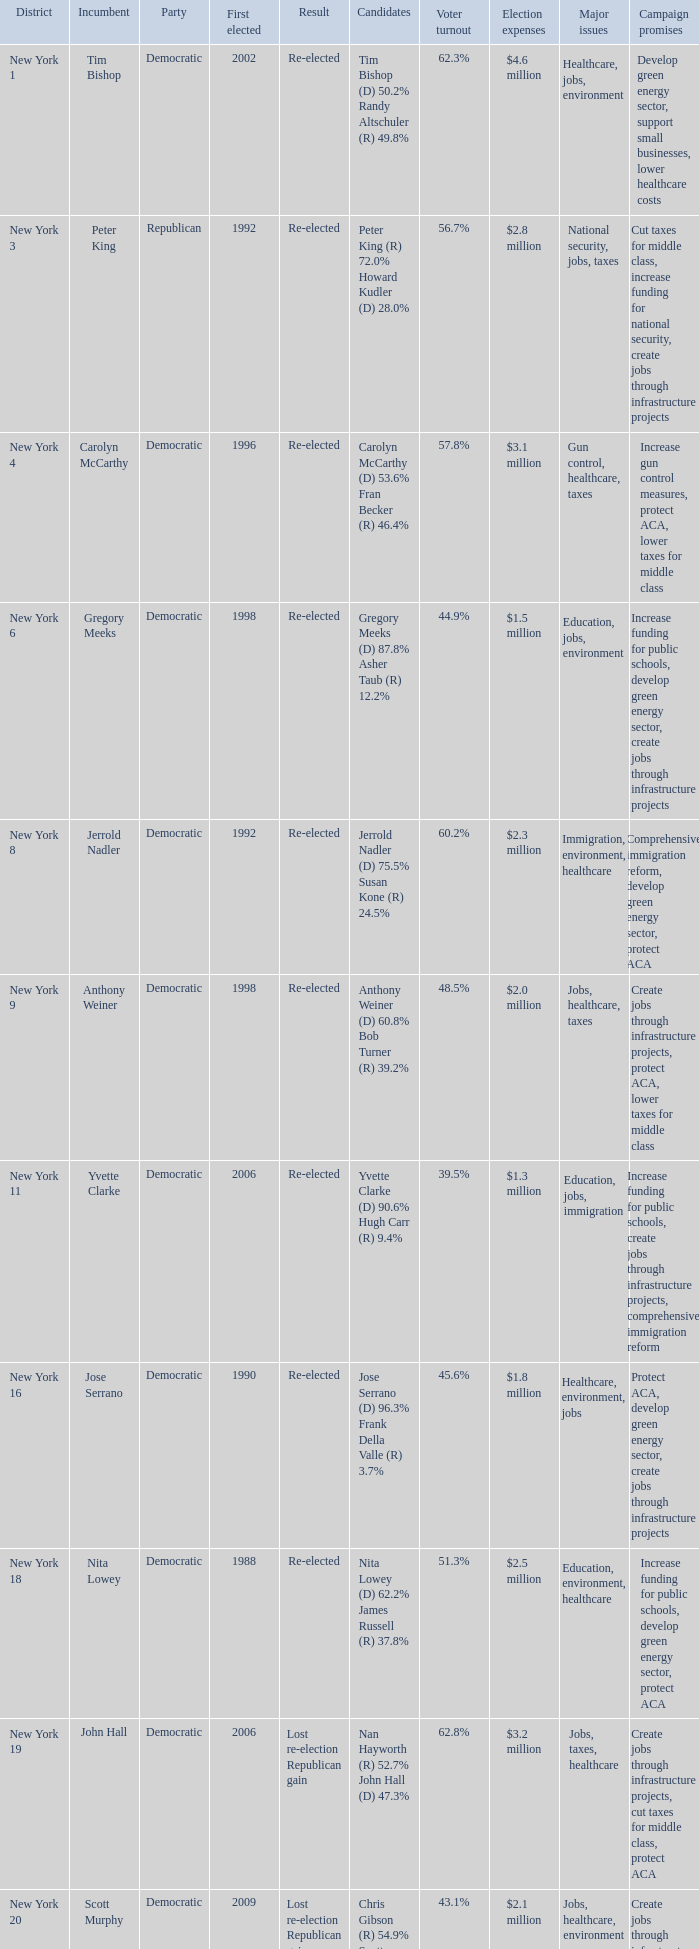Can you parse all the data within this table? {'header': ['District', 'Incumbent', 'Party', 'First elected', 'Result', 'Candidates', 'Voter turnout', 'Election expenses', 'Major issues', 'Campaign promises'], 'rows': [['New York 1', 'Tim Bishop', 'Democratic', '2002', 'Re-elected', 'Tim Bishop (D) 50.2% Randy Altschuler (R) 49.8%', '62.3%', '$4.6 million', 'Healthcare, jobs, environment', 'Develop green energy sector, support small businesses, lower healthcare costs'], ['New York 3', 'Peter King', 'Republican', '1992', 'Re-elected', 'Peter King (R) 72.0% Howard Kudler (D) 28.0%', '56.7%', '$2.8 million', 'National security, jobs, taxes', 'Cut taxes for middle class, increase funding for national security, create jobs through infrastructure projects'], ['New York 4', 'Carolyn McCarthy', 'Democratic', '1996', 'Re-elected', 'Carolyn McCarthy (D) 53.6% Fran Becker (R) 46.4%', '57.8%', '$3.1 million', 'Gun control, healthcare, taxes', 'Increase gun control measures, protect ACA, lower taxes for middle class'], ['New York 6', 'Gregory Meeks', 'Democratic', '1998', 'Re-elected', 'Gregory Meeks (D) 87.8% Asher Taub (R) 12.2%', '44.9%', '$1.5 million', 'Education, jobs, environment', 'Increase funding for public schools, develop green energy sector, create jobs through infrastructure projects'], ['New York 8', 'Jerrold Nadler', 'Democratic', '1992', 'Re-elected', 'Jerrold Nadler (D) 75.5% Susan Kone (R) 24.5%', '60.2%', '$2.3 million', 'Immigration, environment, healthcare', 'Comprehensive immigration reform, develop green energy sector, protect ACA'], ['New York 9', 'Anthony Weiner', 'Democratic', '1998', 'Re-elected', 'Anthony Weiner (D) 60.8% Bob Turner (R) 39.2%', '48.5%', '$2.0 million', 'Jobs, healthcare, taxes', 'Create jobs through infrastructure projects, protect ACA, lower taxes for middle class'], ['New York 11', 'Yvette Clarke', 'Democratic', '2006', 'Re-elected', 'Yvette Clarke (D) 90.6% Hugh Carr (R) 9.4%', '39.5%', '$1.3 million', 'Education, jobs, immigration', 'Increase funding for public schools, create jobs through infrastructure projects, comprehensive immigration reform'], ['New York 16', 'Jose Serrano', 'Democratic', '1990', 'Re-elected', 'Jose Serrano (D) 96.3% Frank Della Valle (R) 3.7%', '45.6%', '$1.8 million', 'Healthcare, environment, jobs', 'Protect ACA, develop green energy sector, create jobs through infrastructure projects'], ['New York 18', 'Nita Lowey', 'Democratic', '1988', 'Re-elected', 'Nita Lowey (D) 62.2% James Russell (R) 37.8%', '51.3%', '$2.5 million', 'Education, environment, healthcare', 'Increase funding for public schools, develop green energy sector, protect ACA'], ['New York 19', 'John Hall', 'Democratic', '2006', 'Lost re-election Republican gain', 'Nan Hayworth (R) 52.7% John Hall (D) 47.3%', '62.8%', '$3.2 million', 'Jobs, taxes, healthcare', 'Create jobs through infrastructure projects, cut taxes for middle class, protect ACA'], ['New York 20', 'Scott Murphy', 'Democratic', '2009', 'Lost re-election Republican gain', 'Chris Gibson (R) 54.9% Scott Murphy (D) 45.1%', '43.1%', '$2.1 million', 'Jobs, healthcare, environment', 'Create jobs through infrastructure projects, protect ACA, develop green energy sector'], ['New York 21', 'Paul Tonko', 'Democratic', '2008', 'Re-elected', 'Paul Tonko (D) 59.3% Theodore Danz (R) 40.7%', '54.9%', '$2.4 million', 'Education, environment, jobs', 'Increase funding for public schools, develop green energy sector, create jobs through infrastructure projects'], ['New York 24', 'Mike Arcuri', 'Democratic', '2006', 'Lost re-election Republican gain', 'Richard L. Hanna (R) 53.1% Mike Arcuri (D) 46.9%', '47.8%', '$2.9 million', 'Jobs, healthcare, taxes', 'Create jobs through infrastructure projects, protect ACA, lower taxes for middle class'], ['New York 25', 'Dan Maffei', 'Democratic', '2008', 'Lost re-election Republican gain', 'Ann Marie Buerkle (R) 50.2% Dan Maffei (D) 49.8%', '63.5%', '$3.4 million', 'Jobs, healthcare, education', 'Create jobs through infrastructure projects, protect ACA, increase funding for public schools'], ['New York 26', 'Chris Lee', 'Republican', '2008', 'Re-elected', 'Chris Lee (R) 73.6% Philip Fedele (D) 26.4%', '50.7%', '$2.2 million', 'Jobs, taxes, national security', 'Create jobs through infrastructure projects, cut taxes for middle class, increase funding for national security'], ['New York 27', 'Brian Higgins', 'Democratic', '2004', 'Re-elected', 'Brian Higgins (D) 60.9% Leonard Roberto (R) 39.1%', '58.3%', '$2.6 million', 'Education, jobs, healthcare', 'Increase funding for public schools, create jobs through infrastructure projects, protect ACA'], ['New York 28', 'Louise Slaughter', 'Democratic', '1986', 'Re-elected', 'Louise Slaughter (D) 64.9% Jill Rowland (R) 35.1%', '52.6%', '$3.1 million', 'Environment, healthcare, jobs', 'Develop green energy sector, protect ACA, create jobs through infrastructure projects']]} Name the party for new york 4 Democratic. 